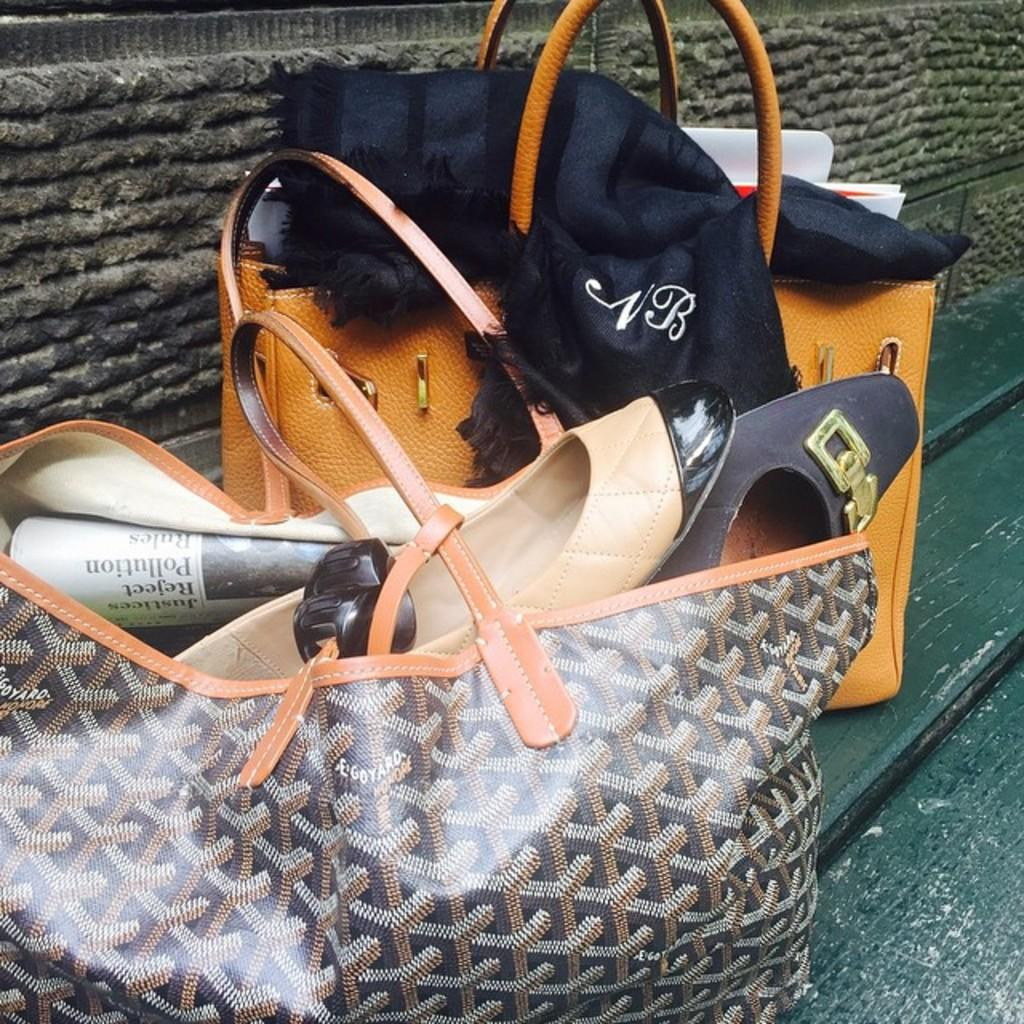What objects are on the bench in the image? There are two handbags on the bench. What items can be found inside one of the handbags? There are shoes and papers in one of the handbags. What type of badge is visible on the apparel of the beginner in the image? There is no beginner or badge present in the image; it only features two handbags on a bench. 